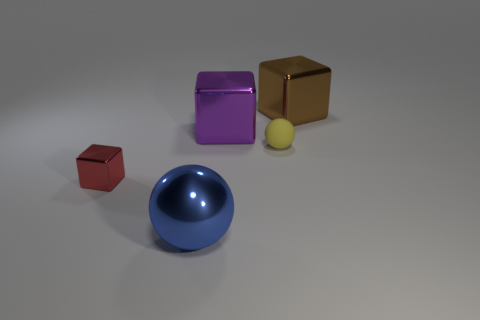Subtract all green blocks. Subtract all brown cylinders. How many blocks are left? 3 Add 5 purple metallic blocks. How many objects exist? 10 Subtract all balls. How many objects are left? 3 Add 4 shiny objects. How many shiny objects are left? 8 Add 2 rubber objects. How many rubber objects exist? 3 Subtract 0 gray blocks. How many objects are left? 5 Subtract all purple things. Subtract all small gray cylinders. How many objects are left? 4 